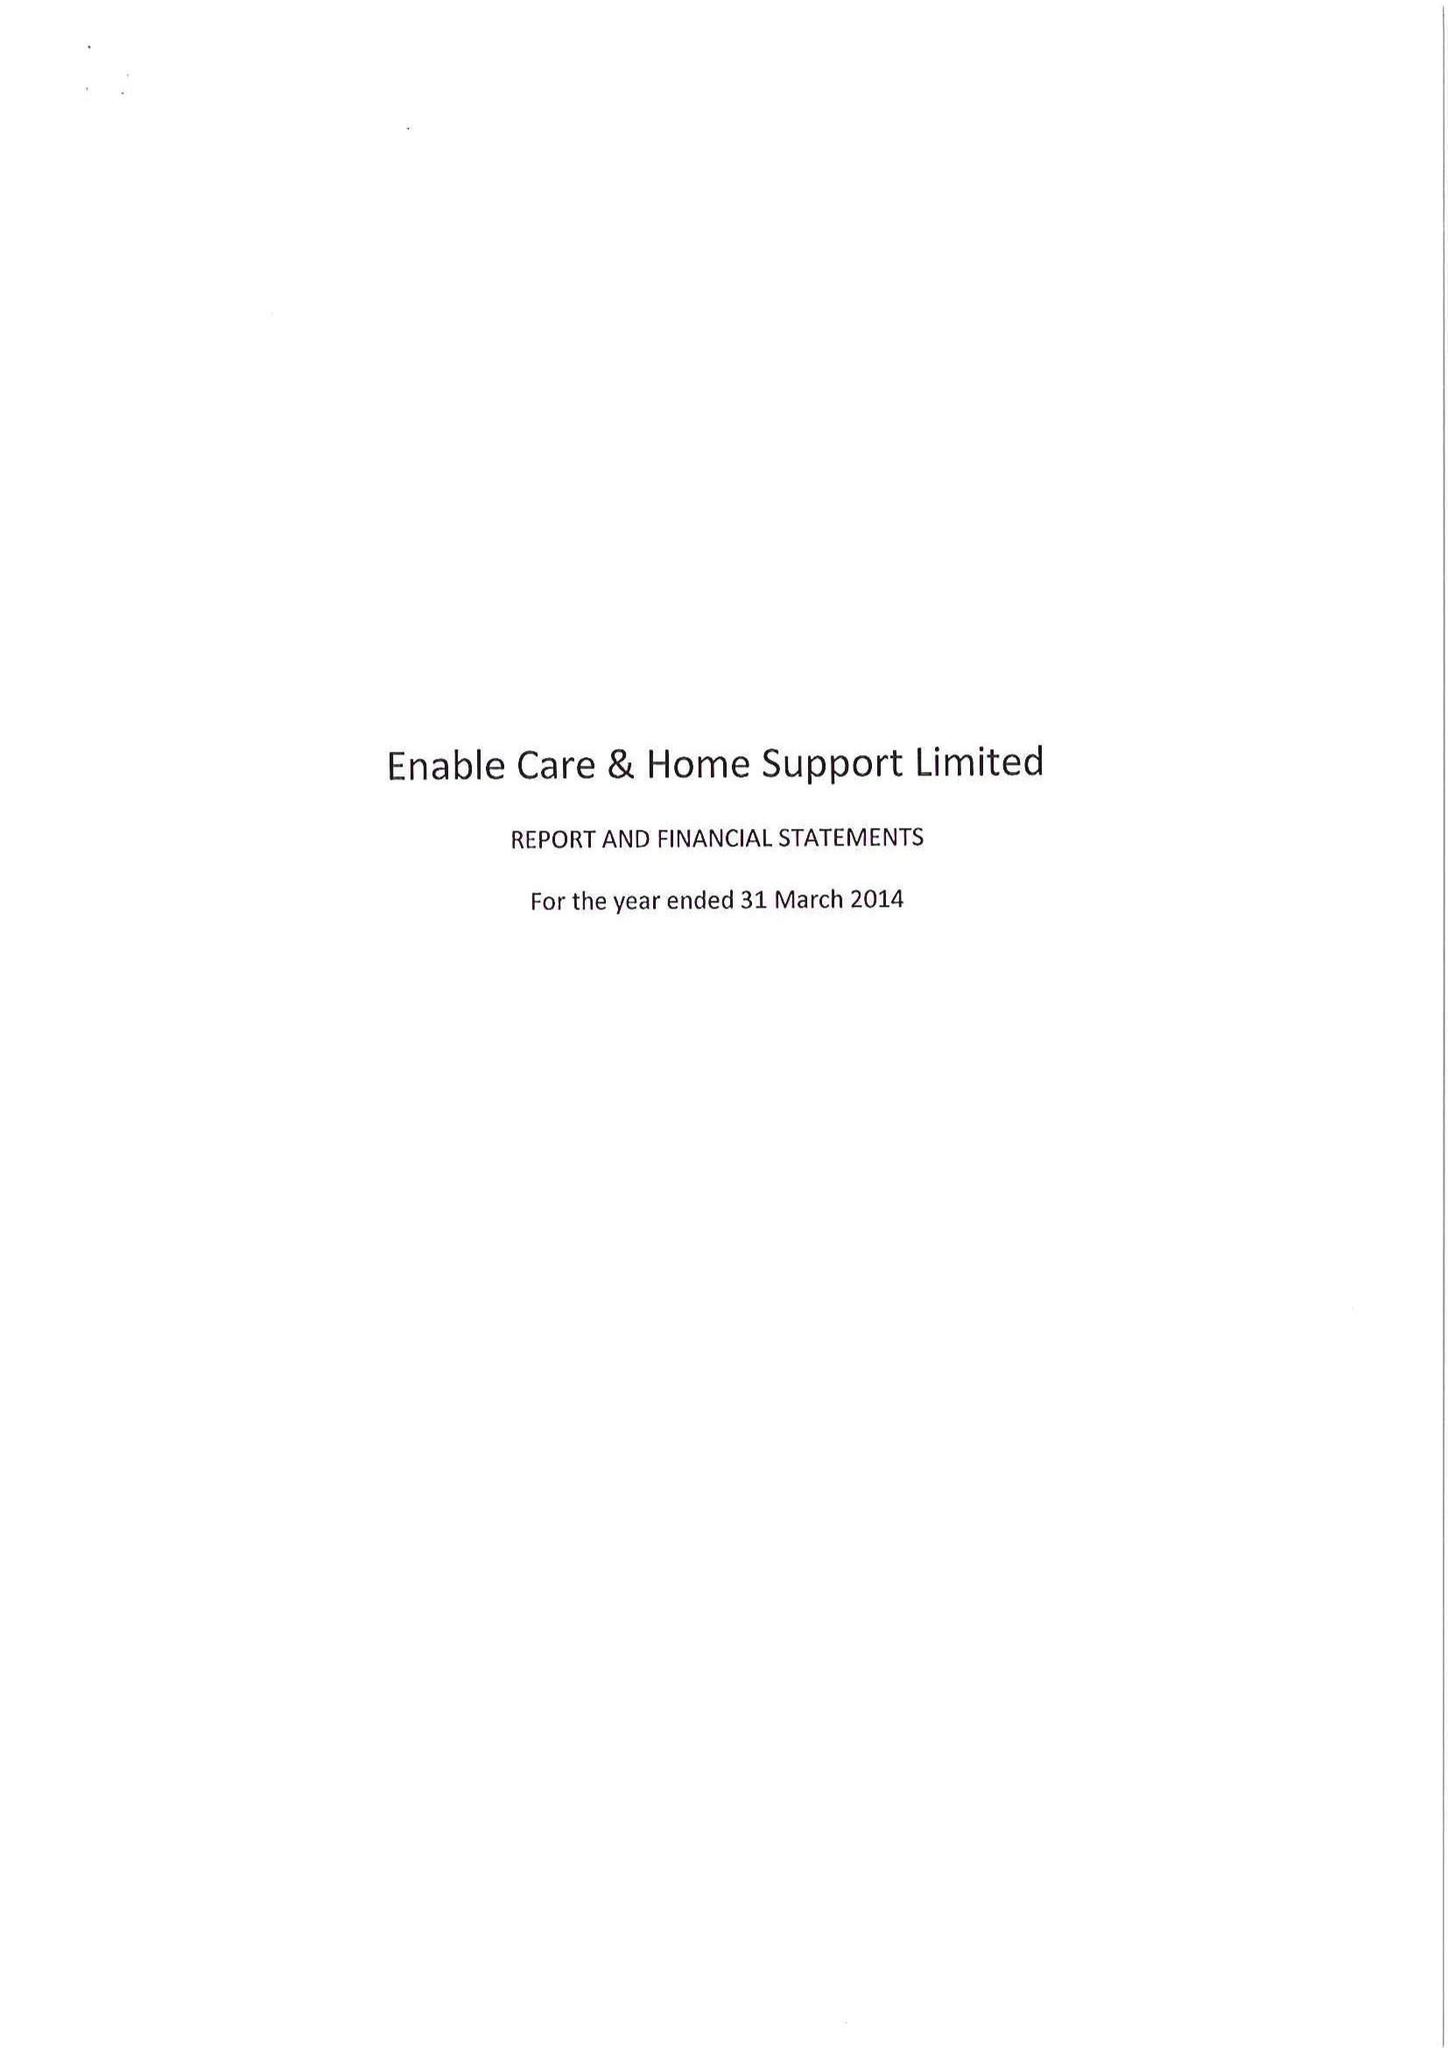What is the value for the income_annually_in_british_pounds?
Answer the question using a single word or phrase. 15133000.00 